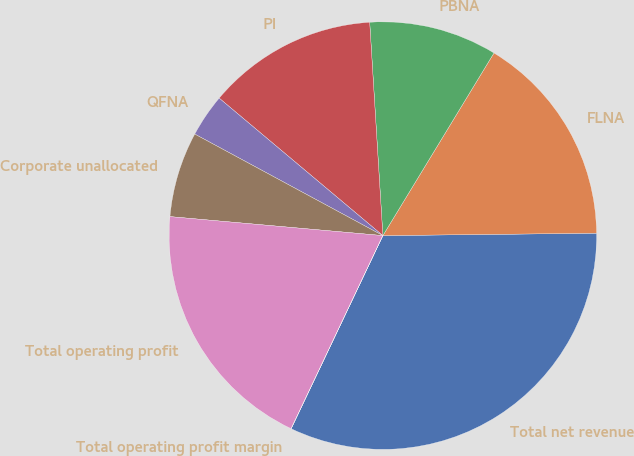Convert chart to OTSL. <chart><loc_0><loc_0><loc_500><loc_500><pie_chart><fcel>Total net revenue<fcel>FLNA<fcel>PBNA<fcel>PI<fcel>QFNA<fcel>Corporate unallocated<fcel>Total operating profit<fcel>Total operating profit margin<nl><fcel>32.23%<fcel>16.12%<fcel>9.68%<fcel>12.9%<fcel>3.24%<fcel>6.46%<fcel>19.35%<fcel>0.01%<nl></chart> 